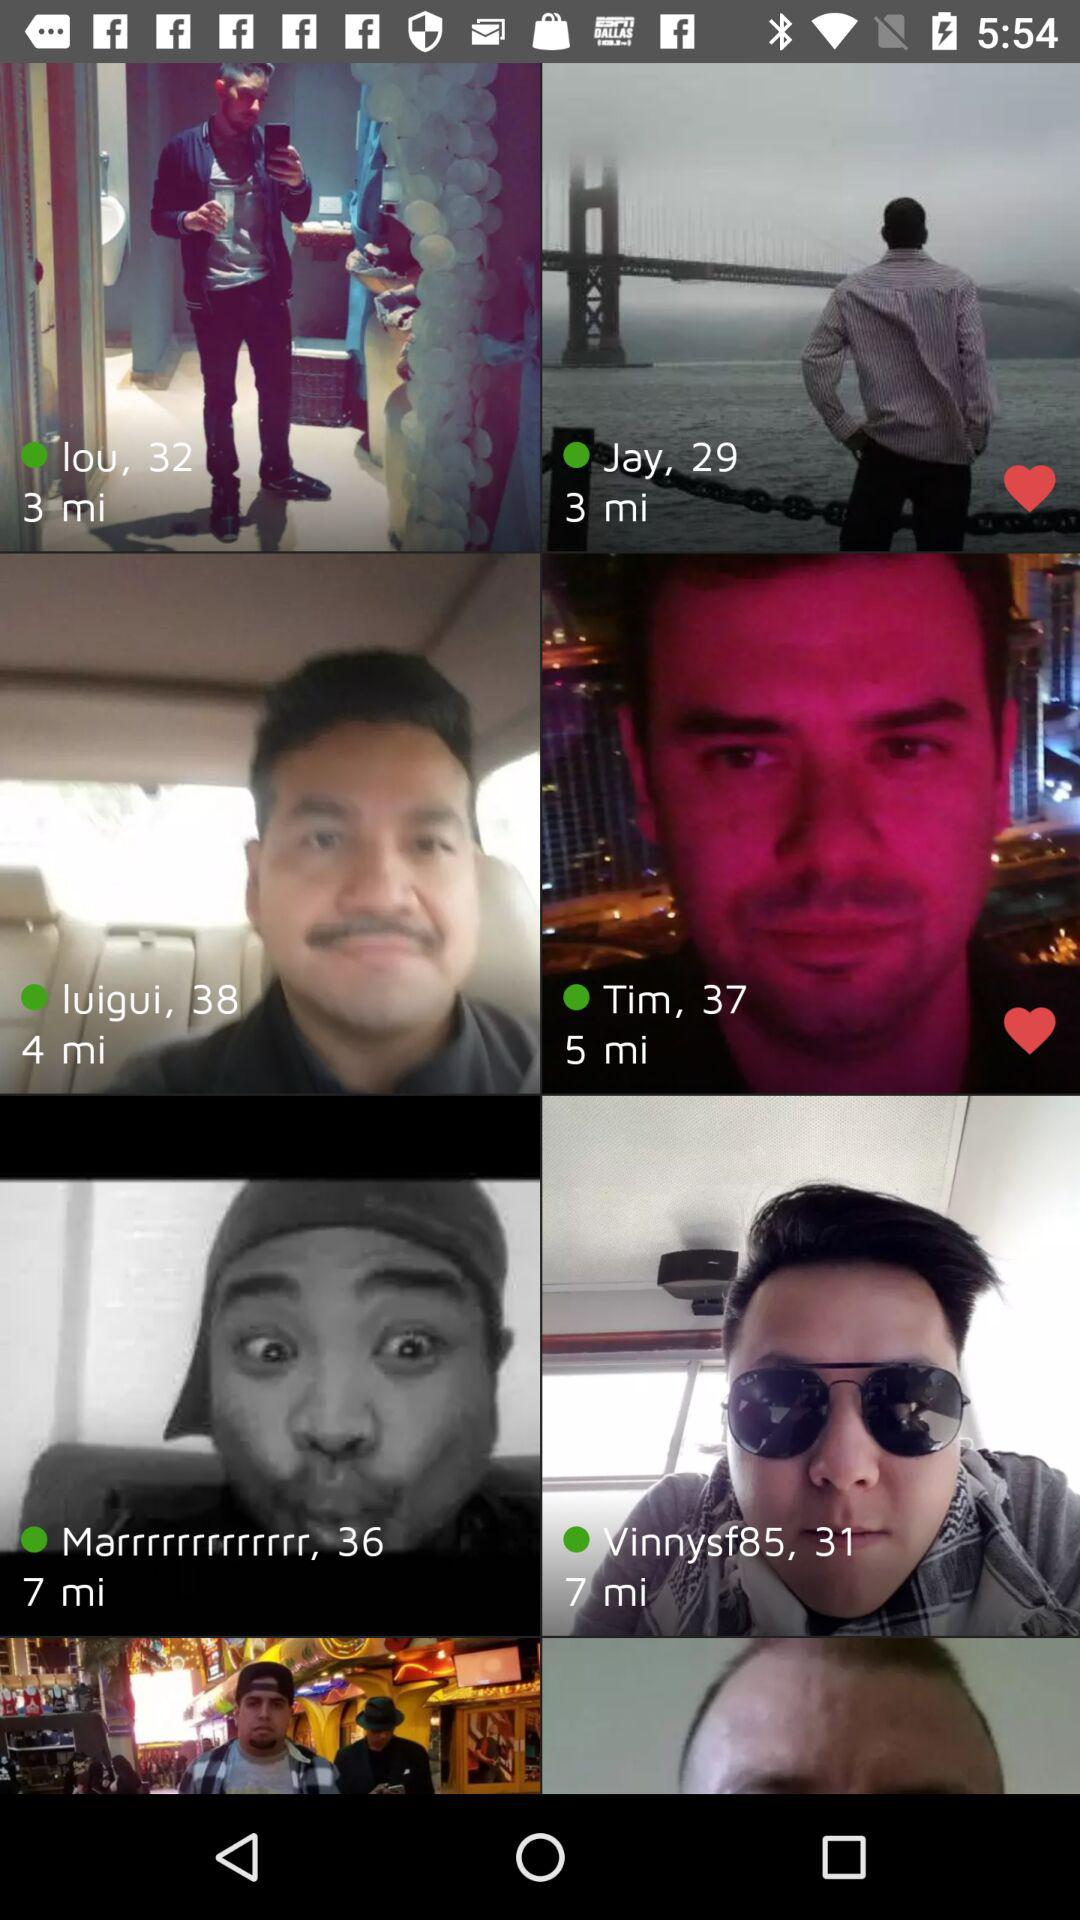What's the age of Jay? The age of Jay is 29 years. 